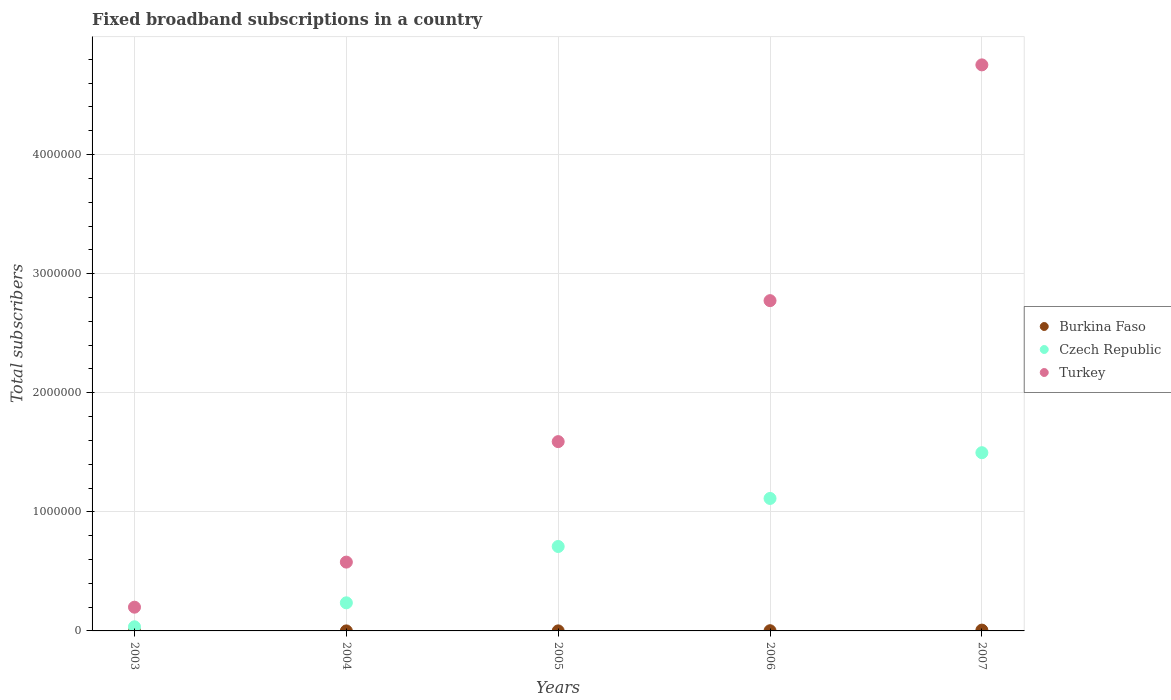How many different coloured dotlines are there?
Your response must be concise. 3. Is the number of dotlines equal to the number of legend labels?
Your response must be concise. Yes. What is the number of broadband subscriptions in Czech Republic in 2004?
Ensure brevity in your answer.  2.36e+05. Across all years, what is the maximum number of broadband subscriptions in Turkey?
Keep it short and to the point. 4.75e+06. Across all years, what is the minimum number of broadband subscriptions in Turkey?
Give a very brief answer. 1.99e+05. What is the total number of broadband subscriptions in Czech Republic in the graph?
Your answer should be compact. 3.59e+06. What is the difference between the number of broadband subscriptions in Turkey in 2005 and that in 2007?
Keep it short and to the point. -3.16e+06. What is the difference between the number of broadband subscriptions in Burkina Faso in 2003 and the number of broadband subscriptions in Czech Republic in 2005?
Ensure brevity in your answer.  -7.09e+05. What is the average number of broadband subscriptions in Burkina Faso per year?
Offer a very short reply. 1826. In the year 2005, what is the difference between the number of broadband subscriptions in Czech Republic and number of broadband subscriptions in Burkina Faso?
Ensure brevity in your answer.  7.09e+05. What is the ratio of the number of broadband subscriptions in Czech Republic in 2005 to that in 2007?
Provide a succinct answer. 0.47. Is the difference between the number of broadband subscriptions in Czech Republic in 2004 and 2007 greater than the difference between the number of broadband subscriptions in Burkina Faso in 2004 and 2007?
Your answer should be very brief. No. What is the difference between the highest and the second highest number of broadband subscriptions in Czech Republic?
Ensure brevity in your answer.  3.84e+05. What is the difference between the highest and the lowest number of broadband subscriptions in Burkina Faso?
Provide a short and direct response. 6587. Is the sum of the number of broadband subscriptions in Burkina Faso in 2003 and 2004 greater than the maximum number of broadband subscriptions in Czech Republic across all years?
Keep it short and to the point. No. Does the number of broadband subscriptions in Turkey monotonically increase over the years?
Provide a succinct answer. Yes. How many dotlines are there?
Ensure brevity in your answer.  3. How many years are there in the graph?
Provide a short and direct response. 5. Does the graph contain grids?
Provide a succinct answer. Yes. How many legend labels are there?
Your response must be concise. 3. What is the title of the graph?
Ensure brevity in your answer.  Fixed broadband subscriptions in a country. What is the label or title of the X-axis?
Give a very brief answer. Years. What is the label or title of the Y-axis?
Offer a terse response. Total subscribers. What is the Total subscribers of Burkina Faso in 2003?
Offer a terse response. 145. What is the Total subscribers in Czech Republic in 2003?
Your answer should be very brief. 3.47e+04. What is the Total subscribers of Turkey in 2003?
Keep it short and to the point. 1.99e+05. What is the Total subscribers of Burkina Faso in 2004?
Provide a short and direct response. 154. What is the Total subscribers of Czech Republic in 2004?
Make the answer very short. 2.36e+05. What is the Total subscribers in Turkey in 2004?
Provide a short and direct response. 5.78e+05. What is the Total subscribers of Burkina Faso in 2005?
Keep it short and to the point. 384. What is the Total subscribers in Czech Republic in 2005?
Give a very brief answer. 7.09e+05. What is the Total subscribers in Turkey in 2005?
Make the answer very short. 1.59e+06. What is the Total subscribers of Burkina Faso in 2006?
Make the answer very short. 1715. What is the Total subscribers of Czech Republic in 2006?
Give a very brief answer. 1.11e+06. What is the Total subscribers of Turkey in 2006?
Provide a succinct answer. 2.77e+06. What is the Total subscribers of Burkina Faso in 2007?
Give a very brief answer. 6732. What is the Total subscribers of Czech Republic in 2007?
Your answer should be very brief. 1.50e+06. What is the Total subscribers of Turkey in 2007?
Give a very brief answer. 4.75e+06. Across all years, what is the maximum Total subscribers in Burkina Faso?
Make the answer very short. 6732. Across all years, what is the maximum Total subscribers of Czech Republic?
Provide a succinct answer. 1.50e+06. Across all years, what is the maximum Total subscribers in Turkey?
Your response must be concise. 4.75e+06. Across all years, what is the minimum Total subscribers in Burkina Faso?
Offer a terse response. 145. Across all years, what is the minimum Total subscribers of Czech Republic?
Your answer should be very brief. 3.47e+04. Across all years, what is the minimum Total subscribers in Turkey?
Provide a succinct answer. 1.99e+05. What is the total Total subscribers in Burkina Faso in the graph?
Your answer should be compact. 9130. What is the total Total subscribers of Czech Republic in the graph?
Make the answer very short. 3.59e+06. What is the total Total subscribers in Turkey in the graph?
Give a very brief answer. 9.89e+06. What is the difference between the Total subscribers in Czech Republic in 2003 and that in 2004?
Give a very brief answer. -2.01e+05. What is the difference between the Total subscribers of Turkey in 2003 and that in 2004?
Offer a very short reply. -3.79e+05. What is the difference between the Total subscribers in Burkina Faso in 2003 and that in 2005?
Your answer should be compact. -239. What is the difference between the Total subscribers of Czech Republic in 2003 and that in 2005?
Your answer should be very brief. -6.74e+05. What is the difference between the Total subscribers in Turkey in 2003 and that in 2005?
Give a very brief answer. -1.39e+06. What is the difference between the Total subscribers in Burkina Faso in 2003 and that in 2006?
Ensure brevity in your answer.  -1570. What is the difference between the Total subscribers of Czech Republic in 2003 and that in 2006?
Provide a succinct answer. -1.08e+06. What is the difference between the Total subscribers of Turkey in 2003 and that in 2006?
Offer a very short reply. -2.57e+06. What is the difference between the Total subscribers of Burkina Faso in 2003 and that in 2007?
Provide a short and direct response. -6587. What is the difference between the Total subscribers of Czech Republic in 2003 and that in 2007?
Keep it short and to the point. -1.46e+06. What is the difference between the Total subscribers in Turkey in 2003 and that in 2007?
Provide a succinct answer. -4.55e+06. What is the difference between the Total subscribers of Burkina Faso in 2004 and that in 2005?
Your response must be concise. -230. What is the difference between the Total subscribers in Czech Republic in 2004 and that in 2005?
Offer a very short reply. -4.73e+05. What is the difference between the Total subscribers in Turkey in 2004 and that in 2005?
Offer a very short reply. -1.01e+06. What is the difference between the Total subscribers of Burkina Faso in 2004 and that in 2006?
Your answer should be compact. -1561. What is the difference between the Total subscribers in Czech Republic in 2004 and that in 2006?
Offer a very short reply. -8.77e+05. What is the difference between the Total subscribers in Turkey in 2004 and that in 2006?
Give a very brief answer. -2.20e+06. What is the difference between the Total subscribers in Burkina Faso in 2004 and that in 2007?
Ensure brevity in your answer.  -6578. What is the difference between the Total subscribers of Czech Republic in 2004 and that in 2007?
Offer a terse response. -1.26e+06. What is the difference between the Total subscribers in Turkey in 2004 and that in 2007?
Your answer should be compact. -4.18e+06. What is the difference between the Total subscribers in Burkina Faso in 2005 and that in 2006?
Your answer should be very brief. -1331. What is the difference between the Total subscribers in Czech Republic in 2005 and that in 2006?
Give a very brief answer. -4.03e+05. What is the difference between the Total subscribers of Turkey in 2005 and that in 2006?
Your answer should be compact. -1.18e+06. What is the difference between the Total subscribers in Burkina Faso in 2005 and that in 2007?
Give a very brief answer. -6348. What is the difference between the Total subscribers of Czech Republic in 2005 and that in 2007?
Provide a succinct answer. -7.88e+05. What is the difference between the Total subscribers in Turkey in 2005 and that in 2007?
Offer a very short reply. -3.16e+06. What is the difference between the Total subscribers of Burkina Faso in 2006 and that in 2007?
Provide a succinct answer. -5017. What is the difference between the Total subscribers of Czech Republic in 2006 and that in 2007?
Provide a succinct answer. -3.84e+05. What is the difference between the Total subscribers of Turkey in 2006 and that in 2007?
Your response must be concise. -1.98e+06. What is the difference between the Total subscribers of Burkina Faso in 2003 and the Total subscribers of Czech Republic in 2004?
Provide a short and direct response. -2.36e+05. What is the difference between the Total subscribers in Burkina Faso in 2003 and the Total subscribers in Turkey in 2004?
Provide a succinct answer. -5.78e+05. What is the difference between the Total subscribers in Czech Republic in 2003 and the Total subscribers in Turkey in 2004?
Provide a short and direct response. -5.43e+05. What is the difference between the Total subscribers of Burkina Faso in 2003 and the Total subscribers of Czech Republic in 2005?
Make the answer very short. -7.09e+05. What is the difference between the Total subscribers in Burkina Faso in 2003 and the Total subscribers in Turkey in 2005?
Your answer should be very brief. -1.59e+06. What is the difference between the Total subscribers of Czech Republic in 2003 and the Total subscribers of Turkey in 2005?
Your response must be concise. -1.56e+06. What is the difference between the Total subscribers in Burkina Faso in 2003 and the Total subscribers in Czech Republic in 2006?
Provide a short and direct response. -1.11e+06. What is the difference between the Total subscribers of Burkina Faso in 2003 and the Total subscribers of Turkey in 2006?
Ensure brevity in your answer.  -2.77e+06. What is the difference between the Total subscribers of Czech Republic in 2003 and the Total subscribers of Turkey in 2006?
Offer a terse response. -2.74e+06. What is the difference between the Total subscribers in Burkina Faso in 2003 and the Total subscribers in Czech Republic in 2007?
Your answer should be compact. -1.50e+06. What is the difference between the Total subscribers in Burkina Faso in 2003 and the Total subscribers in Turkey in 2007?
Your response must be concise. -4.75e+06. What is the difference between the Total subscribers of Czech Republic in 2003 and the Total subscribers of Turkey in 2007?
Give a very brief answer. -4.72e+06. What is the difference between the Total subscribers of Burkina Faso in 2004 and the Total subscribers of Czech Republic in 2005?
Ensure brevity in your answer.  -7.09e+05. What is the difference between the Total subscribers of Burkina Faso in 2004 and the Total subscribers of Turkey in 2005?
Give a very brief answer. -1.59e+06. What is the difference between the Total subscribers in Czech Republic in 2004 and the Total subscribers in Turkey in 2005?
Provide a succinct answer. -1.35e+06. What is the difference between the Total subscribers in Burkina Faso in 2004 and the Total subscribers in Czech Republic in 2006?
Offer a very short reply. -1.11e+06. What is the difference between the Total subscribers in Burkina Faso in 2004 and the Total subscribers in Turkey in 2006?
Provide a succinct answer. -2.77e+06. What is the difference between the Total subscribers in Czech Republic in 2004 and the Total subscribers in Turkey in 2006?
Make the answer very short. -2.54e+06. What is the difference between the Total subscribers of Burkina Faso in 2004 and the Total subscribers of Czech Republic in 2007?
Offer a terse response. -1.50e+06. What is the difference between the Total subscribers in Burkina Faso in 2004 and the Total subscribers in Turkey in 2007?
Your answer should be compact. -4.75e+06. What is the difference between the Total subscribers of Czech Republic in 2004 and the Total subscribers of Turkey in 2007?
Provide a succinct answer. -4.52e+06. What is the difference between the Total subscribers of Burkina Faso in 2005 and the Total subscribers of Czech Republic in 2006?
Your answer should be very brief. -1.11e+06. What is the difference between the Total subscribers of Burkina Faso in 2005 and the Total subscribers of Turkey in 2006?
Make the answer very short. -2.77e+06. What is the difference between the Total subscribers of Czech Republic in 2005 and the Total subscribers of Turkey in 2006?
Your answer should be very brief. -2.06e+06. What is the difference between the Total subscribers in Burkina Faso in 2005 and the Total subscribers in Czech Republic in 2007?
Your answer should be compact. -1.50e+06. What is the difference between the Total subscribers in Burkina Faso in 2005 and the Total subscribers in Turkey in 2007?
Make the answer very short. -4.75e+06. What is the difference between the Total subscribers in Czech Republic in 2005 and the Total subscribers in Turkey in 2007?
Make the answer very short. -4.04e+06. What is the difference between the Total subscribers of Burkina Faso in 2006 and the Total subscribers of Czech Republic in 2007?
Give a very brief answer. -1.50e+06. What is the difference between the Total subscribers of Burkina Faso in 2006 and the Total subscribers of Turkey in 2007?
Keep it short and to the point. -4.75e+06. What is the difference between the Total subscribers of Czech Republic in 2006 and the Total subscribers of Turkey in 2007?
Ensure brevity in your answer.  -3.64e+06. What is the average Total subscribers in Burkina Faso per year?
Give a very brief answer. 1826. What is the average Total subscribers of Czech Republic per year?
Your answer should be very brief. 7.18e+05. What is the average Total subscribers of Turkey per year?
Offer a very short reply. 1.98e+06. In the year 2003, what is the difference between the Total subscribers of Burkina Faso and Total subscribers of Czech Republic?
Provide a succinct answer. -3.45e+04. In the year 2003, what is the difference between the Total subscribers in Burkina Faso and Total subscribers in Turkey?
Offer a terse response. -1.99e+05. In the year 2003, what is the difference between the Total subscribers of Czech Republic and Total subscribers of Turkey?
Provide a succinct answer. -1.65e+05. In the year 2004, what is the difference between the Total subscribers in Burkina Faso and Total subscribers in Czech Republic?
Your response must be concise. -2.36e+05. In the year 2004, what is the difference between the Total subscribers of Burkina Faso and Total subscribers of Turkey?
Provide a succinct answer. -5.78e+05. In the year 2004, what is the difference between the Total subscribers in Czech Republic and Total subscribers in Turkey?
Offer a terse response. -3.42e+05. In the year 2005, what is the difference between the Total subscribers in Burkina Faso and Total subscribers in Czech Republic?
Your answer should be compact. -7.09e+05. In the year 2005, what is the difference between the Total subscribers of Burkina Faso and Total subscribers of Turkey?
Offer a terse response. -1.59e+06. In the year 2005, what is the difference between the Total subscribers in Czech Republic and Total subscribers in Turkey?
Your response must be concise. -8.81e+05. In the year 2006, what is the difference between the Total subscribers in Burkina Faso and Total subscribers in Czech Republic?
Provide a short and direct response. -1.11e+06. In the year 2006, what is the difference between the Total subscribers of Burkina Faso and Total subscribers of Turkey?
Make the answer very short. -2.77e+06. In the year 2006, what is the difference between the Total subscribers in Czech Republic and Total subscribers in Turkey?
Offer a terse response. -1.66e+06. In the year 2007, what is the difference between the Total subscribers of Burkina Faso and Total subscribers of Czech Republic?
Provide a succinct answer. -1.49e+06. In the year 2007, what is the difference between the Total subscribers of Burkina Faso and Total subscribers of Turkey?
Your answer should be compact. -4.75e+06. In the year 2007, what is the difference between the Total subscribers in Czech Republic and Total subscribers in Turkey?
Offer a terse response. -3.26e+06. What is the ratio of the Total subscribers in Burkina Faso in 2003 to that in 2004?
Offer a terse response. 0.94. What is the ratio of the Total subscribers in Czech Republic in 2003 to that in 2004?
Offer a terse response. 0.15. What is the ratio of the Total subscribers in Turkey in 2003 to that in 2004?
Your answer should be very brief. 0.34. What is the ratio of the Total subscribers in Burkina Faso in 2003 to that in 2005?
Make the answer very short. 0.38. What is the ratio of the Total subscribers of Czech Republic in 2003 to that in 2005?
Give a very brief answer. 0.05. What is the ratio of the Total subscribers of Turkey in 2003 to that in 2005?
Provide a short and direct response. 0.13. What is the ratio of the Total subscribers in Burkina Faso in 2003 to that in 2006?
Offer a very short reply. 0.08. What is the ratio of the Total subscribers in Czech Republic in 2003 to that in 2006?
Give a very brief answer. 0.03. What is the ratio of the Total subscribers of Turkey in 2003 to that in 2006?
Keep it short and to the point. 0.07. What is the ratio of the Total subscribers in Burkina Faso in 2003 to that in 2007?
Provide a succinct answer. 0.02. What is the ratio of the Total subscribers in Czech Republic in 2003 to that in 2007?
Make the answer very short. 0.02. What is the ratio of the Total subscribers in Turkey in 2003 to that in 2007?
Offer a terse response. 0.04. What is the ratio of the Total subscribers of Burkina Faso in 2004 to that in 2005?
Give a very brief answer. 0.4. What is the ratio of the Total subscribers of Czech Republic in 2004 to that in 2005?
Your answer should be compact. 0.33. What is the ratio of the Total subscribers in Turkey in 2004 to that in 2005?
Make the answer very short. 0.36. What is the ratio of the Total subscribers of Burkina Faso in 2004 to that in 2006?
Keep it short and to the point. 0.09. What is the ratio of the Total subscribers in Czech Republic in 2004 to that in 2006?
Your answer should be compact. 0.21. What is the ratio of the Total subscribers of Turkey in 2004 to that in 2006?
Make the answer very short. 0.21. What is the ratio of the Total subscribers in Burkina Faso in 2004 to that in 2007?
Offer a terse response. 0.02. What is the ratio of the Total subscribers of Czech Republic in 2004 to that in 2007?
Offer a terse response. 0.16. What is the ratio of the Total subscribers of Turkey in 2004 to that in 2007?
Offer a very short reply. 0.12. What is the ratio of the Total subscribers of Burkina Faso in 2005 to that in 2006?
Make the answer very short. 0.22. What is the ratio of the Total subscribers of Czech Republic in 2005 to that in 2006?
Your answer should be compact. 0.64. What is the ratio of the Total subscribers of Turkey in 2005 to that in 2006?
Offer a terse response. 0.57. What is the ratio of the Total subscribers in Burkina Faso in 2005 to that in 2007?
Provide a short and direct response. 0.06. What is the ratio of the Total subscribers of Czech Republic in 2005 to that in 2007?
Offer a very short reply. 0.47. What is the ratio of the Total subscribers in Turkey in 2005 to that in 2007?
Provide a short and direct response. 0.33. What is the ratio of the Total subscribers in Burkina Faso in 2006 to that in 2007?
Make the answer very short. 0.25. What is the ratio of the Total subscribers of Czech Republic in 2006 to that in 2007?
Provide a short and direct response. 0.74. What is the ratio of the Total subscribers of Turkey in 2006 to that in 2007?
Provide a short and direct response. 0.58. What is the difference between the highest and the second highest Total subscribers in Burkina Faso?
Provide a short and direct response. 5017. What is the difference between the highest and the second highest Total subscribers of Czech Republic?
Make the answer very short. 3.84e+05. What is the difference between the highest and the second highest Total subscribers in Turkey?
Make the answer very short. 1.98e+06. What is the difference between the highest and the lowest Total subscribers of Burkina Faso?
Offer a terse response. 6587. What is the difference between the highest and the lowest Total subscribers of Czech Republic?
Provide a succinct answer. 1.46e+06. What is the difference between the highest and the lowest Total subscribers in Turkey?
Offer a terse response. 4.55e+06. 